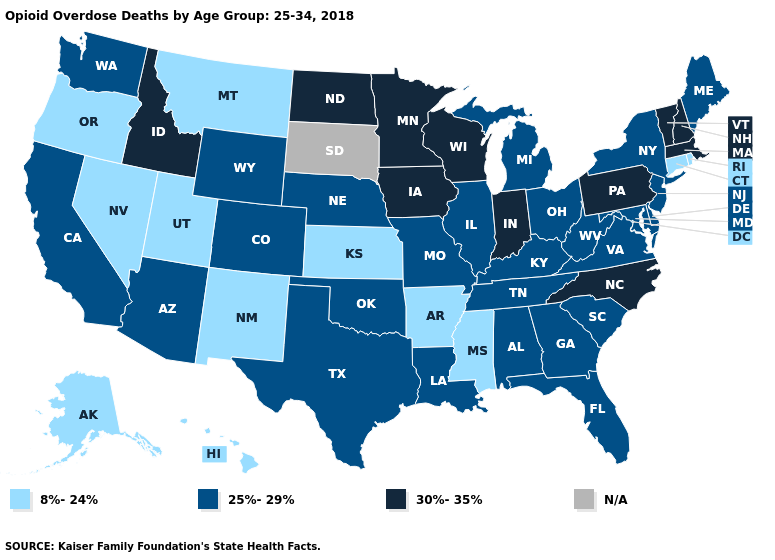What is the highest value in the West ?
Be succinct. 30%-35%. What is the lowest value in the USA?
Short answer required. 8%-24%. What is the lowest value in states that border Tennessee?
Write a very short answer. 8%-24%. What is the value of Alabama?
Give a very brief answer. 25%-29%. Does the map have missing data?
Keep it brief. Yes. What is the highest value in the USA?
Short answer required. 30%-35%. Name the states that have a value in the range 25%-29%?
Keep it brief. Alabama, Arizona, California, Colorado, Delaware, Florida, Georgia, Illinois, Kentucky, Louisiana, Maine, Maryland, Michigan, Missouri, Nebraska, New Jersey, New York, Ohio, Oklahoma, South Carolina, Tennessee, Texas, Virginia, Washington, West Virginia, Wyoming. Among the states that border Idaho , does Wyoming have the highest value?
Give a very brief answer. Yes. What is the highest value in the South ?
Give a very brief answer. 30%-35%. Does the first symbol in the legend represent the smallest category?
Quick response, please. Yes. What is the value of Vermont?
Quick response, please. 30%-35%. Name the states that have a value in the range 30%-35%?
Concise answer only. Idaho, Indiana, Iowa, Massachusetts, Minnesota, New Hampshire, North Carolina, North Dakota, Pennsylvania, Vermont, Wisconsin. Name the states that have a value in the range 8%-24%?
Keep it brief. Alaska, Arkansas, Connecticut, Hawaii, Kansas, Mississippi, Montana, Nevada, New Mexico, Oregon, Rhode Island, Utah. Name the states that have a value in the range N/A?
Quick response, please. South Dakota. Name the states that have a value in the range 25%-29%?
Answer briefly. Alabama, Arizona, California, Colorado, Delaware, Florida, Georgia, Illinois, Kentucky, Louisiana, Maine, Maryland, Michigan, Missouri, Nebraska, New Jersey, New York, Ohio, Oklahoma, South Carolina, Tennessee, Texas, Virginia, Washington, West Virginia, Wyoming. 